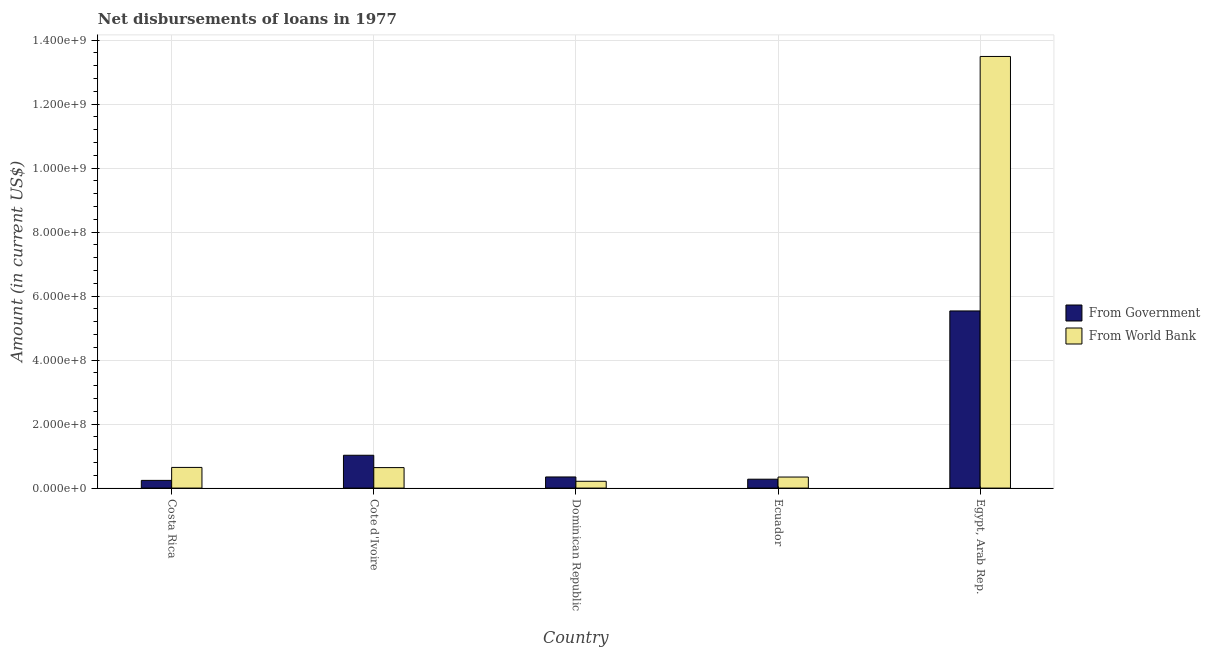How many different coloured bars are there?
Keep it short and to the point. 2. Are the number of bars on each tick of the X-axis equal?
Provide a succinct answer. Yes. What is the label of the 2nd group of bars from the left?
Give a very brief answer. Cote d'Ivoire. What is the net disbursements of loan from government in Dominican Republic?
Your answer should be very brief. 3.48e+07. Across all countries, what is the maximum net disbursements of loan from government?
Keep it short and to the point. 5.54e+08. Across all countries, what is the minimum net disbursements of loan from government?
Provide a short and direct response. 2.41e+07. In which country was the net disbursements of loan from government maximum?
Give a very brief answer. Egypt, Arab Rep. In which country was the net disbursements of loan from world bank minimum?
Make the answer very short. Dominican Republic. What is the total net disbursements of loan from world bank in the graph?
Provide a short and direct response. 1.53e+09. What is the difference between the net disbursements of loan from government in Cote d'Ivoire and that in Dominican Republic?
Make the answer very short. 6.78e+07. What is the difference between the net disbursements of loan from world bank in Ecuador and the net disbursements of loan from government in Egypt, Arab Rep.?
Offer a terse response. -5.19e+08. What is the average net disbursements of loan from world bank per country?
Offer a very short reply. 3.07e+08. What is the difference between the net disbursements of loan from world bank and net disbursements of loan from government in Egypt, Arab Rep.?
Ensure brevity in your answer.  7.95e+08. What is the ratio of the net disbursements of loan from world bank in Costa Rica to that in Egypt, Arab Rep.?
Provide a succinct answer. 0.05. What is the difference between the highest and the second highest net disbursements of loan from world bank?
Ensure brevity in your answer.  1.28e+09. What is the difference between the highest and the lowest net disbursements of loan from government?
Your response must be concise. 5.29e+08. Is the sum of the net disbursements of loan from government in Cote d'Ivoire and Ecuador greater than the maximum net disbursements of loan from world bank across all countries?
Your answer should be very brief. No. What does the 1st bar from the left in Egypt, Arab Rep. represents?
Offer a very short reply. From Government. What does the 1st bar from the right in Cote d'Ivoire represents?
Make the answer very short. From World Bank. Are all the bars in the graph horizontal?
Provide a short and direct response. No. What is the difference between two consecutive major ticks on the Y-axis?
Make the answer very short. 2.00e+08. Does the graph contain grids?
Provide a short and direct response. Yes. Where does the legend appear in the graph?
Your answer should be compact. Center right. How many legend labels are there?
Your answer should be compact. 2. How are the legend labels stacked?
Ensure brevity in your answer.  Vertical. What is the title of the graph?
Offer a terse response. Net disbursements of loans in 1977. Does "Rural Population" appear as one of the legend labels in the graph?
Offer a very short reply. No. What is the label or title of the Y-axis?
Keep it short and to the point. Amount (in current US$). What is the Amount (in current US$) of From Government in Costa Rica?
Offer a terse response. 2.41e+07. What is the Amount (in current US$) in From World Bank in Costa Rica?
Provide a succinct answer. 6.46e+07. What is the Amount (in current US$) of From Government in Cote d'Ivoire?
Your answer should be very brief. 1.03e+08. What is the Amount (in current US$) of From World Bank in Cote d'Ivoire?
Give a very brief answer. 6.40e+07. What is the Amount (in current US$) in From Government in Dominican Republic?
Your answer should be very brief. 3.48e+07. What is the Amount (in current US$) in From World Bank in Dominican Republic?
Offer a terse response. 2.13e+07. What is the Amount (in current US$) of From Government in Ecuador?
Offer a very short reply. 2.78e+07. What is the Amount (in current US$) in From World Bank in Ecuador?
Your answer should be compact. 3.45e+07. What is the Amount (in current US$) of From Government in Egypt, Arab Rep.?
Ensure brevity in your answer.  5.54e+08. What is the Amount (in current US$) in From World Bank in Egypt, Arab Rep.?
Make the answer very short. 1.35e+09. Across all countries, what is the maximum Amount (in current US$) in From Government?
Provide a succinct answer. 5.54e+08. Across all countries, what is the maximum Amount (in current US$) of From World Bank?
Make the answer very short. 1.35e+09. Across all countries, what is the minimum Amount (in current US$) in From Government?
Your answer should be very brief. 2.41e+07. Across all countries, what is the minimum Amount (in current US$) of From World Bank?
Keep it short and to the point. 2.13e+07. What is the total Amount (in current US$) in From Government in the graph?
Your answer should be compact. 7.43e+08. What is the total Amount (in current US$) in From World Bank in the graph?
Offer a terse response. 1.53e+09. What is the difference between the Amount (in current US$) in From Government in Costa Rica and that in Cote d'Ivoire?
Make the answer very short. -7.85e+07. What is the difference between the Amount (in current US$) of From World Bank in Costa Rica and that in Cote d'Ivoire?
Your response must be concise. 5.95e+05. What is the difference between the Amount (in current US$) in From Government in Costa Rica and that in Dominican Republic?
Your response must be concise. -1.07e+07. What is the difference between the Amount (in current US$) of From World Bank in Costa Rica and that in Dominican Republic?
Your answer should be very brief. 4.33e+07. What is the difference between the Amount (in current US$) of From Government in Costa Rica and that in Ecuador?
Keep it short and to the point. -3.72e+06. What is the difference between the Amount (in current US$) of From World Bank in Costa Rica and that in Ecuador?
Keep it short and to the point. 3.01e+07. What is the difference between the Amount (in current US$) in From Government in Costa Rica and that in Egypt, Arab Rep.?
Offer a terse response. -5.29e+08. What is the difference between the Amount (in current US$) of From World Bank in Costa Rica and that in Egypt, Arab Rep.?
Offer a terse response. -1.28e+09. What is the difference between the Amount (in current US$) of From Government in Cote d'Ivoire and that in Dominican Republic?
Make the answer very short. 6.78e+07. What is the difference between the Amount (in current US$) in From World Bank in Cote d'Ivoire and that in Dominican Republic?
Give a very brief answer. 4.27e+07. What is the difference between the Amount (in current US$) in From Government in Cote d'Ivoire and that in Ecuador?
Keep it short and to the point. 7.48e+07. What is the difference between the Amount (in current US$) of From World Bank in Cote d'Ivoire and that in Ecuador?
Your answer should be compact. 2.95e+07. What is the difference between the Amount (in current US$) of From Government in Cote d'Ivoire and that in Egypt, Arab Rep.?
Give a very brief answer. -4.51e+08. What is the difference between the Amount (in current US$) of From World Bank in Cote d'Ivoire and that in Egypt, Arab Rep.?
Your response must be concise. -1.28e+09. What is the difference between the Amount (in current US$) of From Government in Dominican Republic and that in Ecuador?
Ensure brevity in your answer.  6.99e+06. What is the difference between the Amount (in current US$) in From World Bank in Dominican Republic and that in Ecuador?
Offer a terse response. -1.32e+07. What is the difference between the Amount (in current US$) of From Government in Dominican Republic and that in Egypt, Arab Rep.?
Make the answer very short. -5.19e+08. What is the difference between the Amount (in current US$) in From World Bank in Dominican Republic and that in Egypt, Arab Rep.?
Your response must be concise. -1.33e+09. What is the difference between the Amount (in current US$) in From Government in Ecuador and that in Egypt, Arab Rep.?
Your answer should be very brief. -5.26e+08. What is the difference between the Amount (in current US$) of From World Bank in Ecuador and that in Egypt, Arab Rep.?
Provide a succinct answer. -1.31e+09. What is the difference between the Amount (in current US$) in From Government in Costa Rica and the Amount (in current US$) in From World Bank in Cote d'Ivoire?
Offer a very short reply. -3.99e+07. What is the difference between the Amount (in current US$) in From Government in Costa Rica and the Amount (in current US$) in From World Bank in Dominican Republic?
Provide a short and direct response. 2.78e+06. What is the difference between the Amount (in current US$) in From Government in Costa Rica and the Amount (in current US$) in From World Bank in Ecuador?
Keep it short and to the point. -1.05e+07. What is the difference between the Amount (in current US$) of From Government in Costa Rica and the Amount (in current US$) of From World Bank in Egypt, Arab Rep.?
Give a very brief answer. -1.32e+09. What is the difference between the Amount (in current US$) of From Government in Cote d'Ivoire and the Amount (in current US$) of From World Bank in Dominican Republic?
Your response must be concise. 8.13e+07. What is the difference between the Amount (in current US$) of From Government in Cote d'Ivoire and the Amount (in current US$) of From World Bank in Ecuador?
Make the answer very short. 6.81e+07. What is the difference between the Amount (in current US$) of From Government in Cote d'Ivoire and the Amount (in current US$) of From World Bank in Egypt, Arab Rep.?
Offer a very short reply. -1.25e+09. What is the difference between the Amount (in current US$) of From Government in Dominican Republic and the Amount (in current US$) of From World Bank in Ecuador?
Offer a terse response. 2.53e+05. What is the difference between the Amount (in current US$) in From Government in Dominican Republic and the Amount (in current US$) in From World Bank in Egypt, Arab Rep.?
Provide a succinct answer. -1.31e+09. What is the difference between the Amount (in current US$) in From Government in Ecuador and the Amount (in current US$) in From World Bank in Egypt, Arab Rep.?
Your answer should be compact. -1.32e+09. What is the average Amount (in current US$) of From Government per country?
Give a very brief answer. 1.49e+08. What is the average Amount (in current US$) of From World Bank per country?
Give a very brief answer. 3.07e+08. What is the difference between the Amount (in current US$) of From Government and Amount (in current US$) of From World Bank in Costa Rica?
Give a very brief answer. -4.05e+07. What is the difference between the Amount (in current US$) in From Government and Amount (in current US$) in From World Bank in Cote d'Ivoire?
Your answer should be compact. 3.86e+07. What is the difference between the Amount (in current US$) in From Government and Amount (in current US$) in From World Bank in Dominican Republic?
Offer a terse response. 1.35e+07. What is the difference between the Amount (in current US$) in From Government and Amount (in current US$) in From World Bank in Ecuador?
Offer a very short reply. -6.74e+06. What is the difference between the Amount (in current US$) in From Government and Amount (in current US$) in From World Bank in Egypt, Arab Rep.?
Give a very brief answer. -7.95e+08. What is the ratio of the Amount (in current US$) of From Government in Costa Rica to that in Cote d'Ivoire?
Ensure brevity in your answer.  0.23. What is the ratio of the Amount (in current US$) in From World Bank in Costa Rica to that in Cote d'Ivoire?
Keep it short and to the point. 1.01. What is the ratio of the Amount (in current US$) in From Government in Costa Rica to that in Dominican Republic?
Your answer should be very brief. 0.69. What is the ratio of the Amount (in current US$) in From World Bank in Costa Rica to that in Dominican Republic?
Make the answer very short. 3.03. What is the ratio of the Amount (in current US$) of From Government in Costa Rica to that in Ecuador?
Provide a succinct answer. 0.87. What is the ratio of the Amount (in current US$) in From World Bank in Costa Rica to that in Ecuador?
Give a very brief answer. 1.87. What is the ratio of the Amount (in current US$) in From Government in Costa Rica to that in Egypt, Arab Rep.?
Your response must be concise. 0.04. What is the ratio of the Amount (in current US$) of From World Bank in Costa Rica to that in Egypt, Arab Rep.?
Keep it short and to the point. 0.05. What is the ratio of the Amount (in current US$) of From Government in Cote d'Ivoire to that in Dominican Republic?
Your answer should be very brief. 2.95. What is the ratio of the Amount (in current US$) in From World Bank in Cote d'Ivoire to that in Dominican Republic?
Provide a short and direct response. 3.01. What is the ratio of the Amount (in current US$) in From Government in Cote d'Ivoire to that in Ecuador?
Your answer should be compact. 3.69. What is the ratio of the Amount (in current US$) of From World Bank in Cote d'Ivoire to that in Ecuador?
Give a very brief answer. 1.85. What is the ratio of the Amount (in current US$) in From Government in Cote d'Ivoire to that in Egypt, Arab Rep.?
Keep it short and to the point. 0.19. What is the ratio of the Amount (in current US$) of From World Bank in Cote d'Ivoire to that in Egypt, Arab Rep.?
Your response must be concise. 0.05. What is the ratio of the Amount (in current US$) of From Government in Dominican Republic to that in Ecuador?
Offer a terse response. 1.25. What is the ratio of the Amount (in current US$) in From World Bank in Dominican Republic to that in Ecuador?
Your answer should be compact. 0.62. What is the ratio of the Amount (in current US$) in From Government in Dominican Republic to that in Egypt, Arab Rep.?
Your answer should be very brief. 0.06. What is the ratio of the Amount (in current US$) of From World Bank in Dominican Republic to that in Egypt, Arab Rep.?
Provide a succinct answer. 0.02. What is the ratio of the Amount (in current US$) of From Government in Ecuador to that in Egypt, Arab Rep.?
Provide a short and direct response. 0.05. What is the ratio of the Amount (in current US$) of From World Bank in Ecuador to that in Egypt, Arab Rep.?
Provide a succinct answer. 0.03. What is the difference between the highest and the second highest Amount (in current US$) in From Government?
Your answer should be very brief. 4.51e+08. What is the difference between the highest and the second highest Amount (in current US$) of From World Bank?
Keep it short and to the point. 1.28e+09. What is the difference between the highest and the lowest Amount (in current US$) of From Government?
Provide a short and direct response. 5.29e+08. What is the difference between the highest and the lowest Amount (in current US$) in From World Bank?
Give a very brief answer. 1.33e+09. 